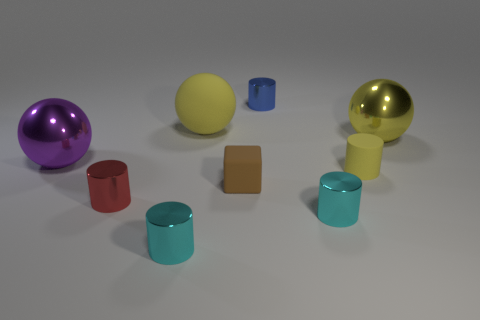Is there a cylinder of the same color as the large matte sphere?
Keep it short and to the point. Yes. What color is the block that is the same size as the blue cylinder?
Provide a short and direct response. Brown. Do the tiny yellow thing and the small blue metallic object have the same shape?
Ensure brevity in your answer.  Yes. There is a small thing that is behind the large yellow shiny thing; what material is it?
Give a very brief answer. Metal. What is the color of the small matte cube?
Offer a terse response. Brown. Is the size of the shiny cylinder behind the tiny rubber cylinder the same as the cyan object to the left of the tiny brown object?
Provide a short and direct response. Yes. There is a shiny object that is to the left of the tiny rubber cylinder and behind the big purple object; how big is it?
Keep it short and to the point. Small. There is another large matte object that is the same shape as the big purple thing; what is its color?
Offer a terse response. Yellow. Is the number of cyan metal objects to the left of the small brown rubber thing greater than the number of small blue cylinders in front of the small yellow matte cylinder?
Ensure brevity in your answer.  Yes. How many other objects are the same shape as the purple metal object?
Offer a very short reply. 2. 